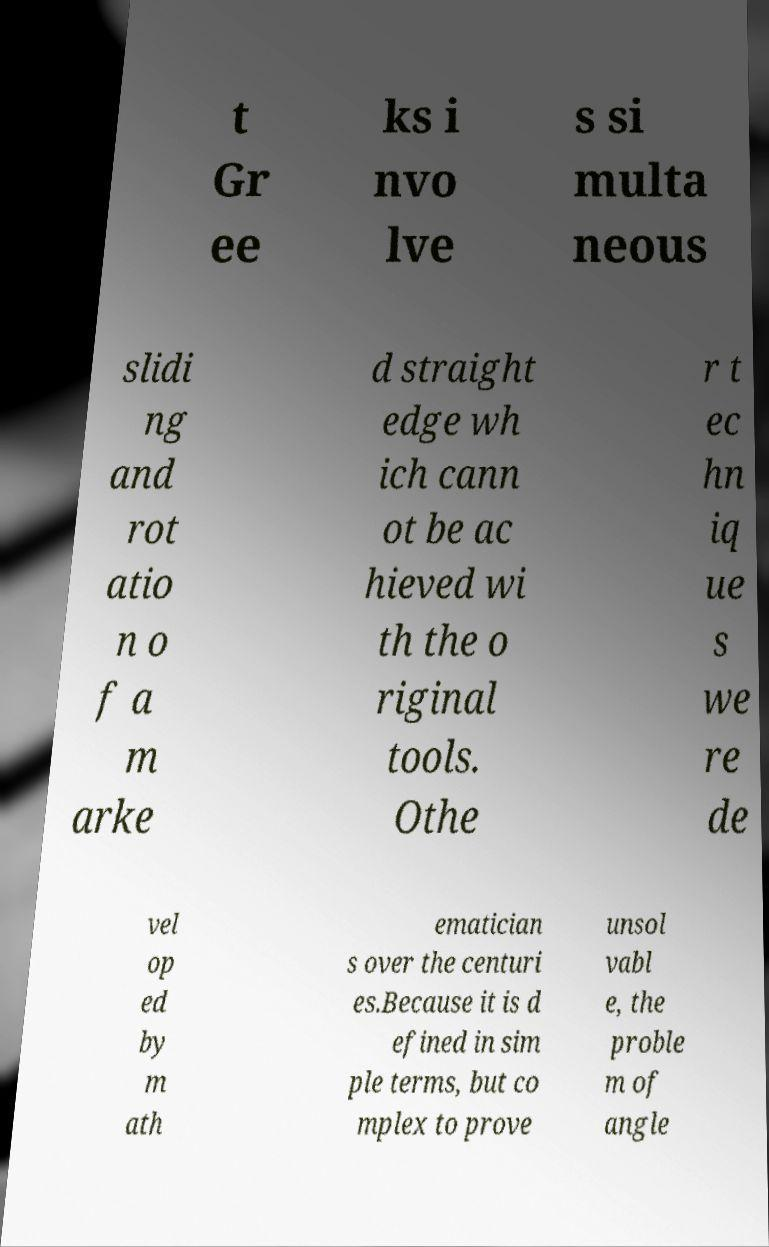Please read and relay the text visible in this image. What does it say? t Gr ee ks i nvo lve s si multa neous slidi ng and rot atio n o f a m arke d straight edge wh ich cann ot be ac hieved wi th the o riginal tools. Othe r t ec hn iq ue s we re de vel op ed by m ath ematician s over the centuri es.Because it is d efined in sim ple terms, but co mplex to prove unsol vabl e, the proble m of angle 